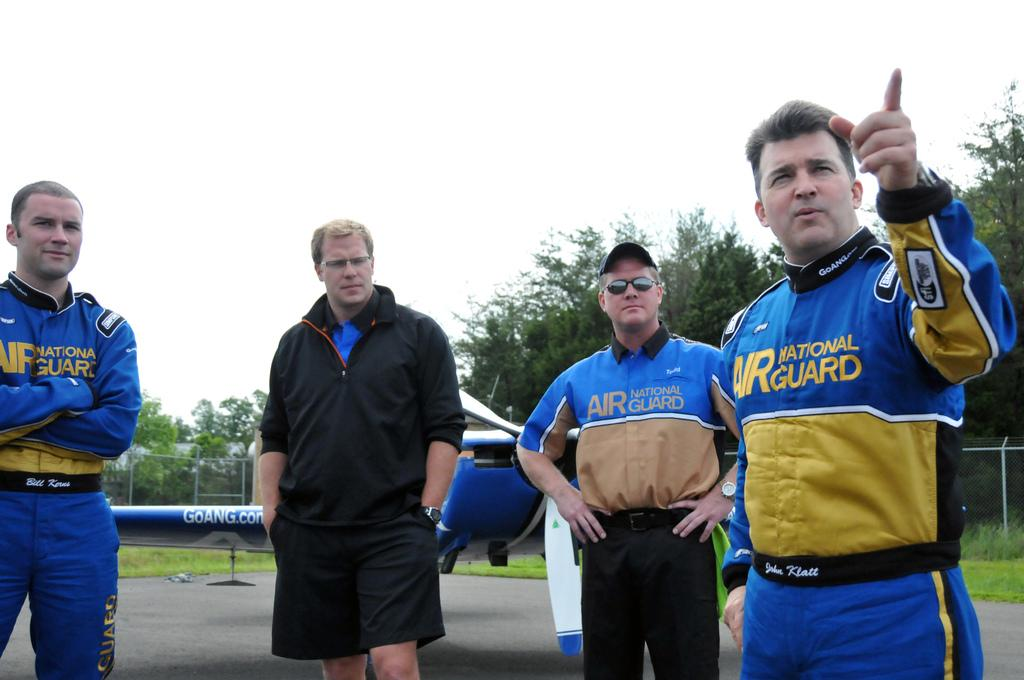How many people are in the front of the image? There are four persons standing in the front of the image. What can be seen in the background of the image? There is a blue color plane, a fence, grass, trees, and the sky visible at the top of the image. Can you see the toes of the persons in the image? The image does not show the toes of the persons; it only shows them standing from the waist up. What type of grass is being washed in the image? There is no grass being washed in the image; it is simply present as part of the landscape. 